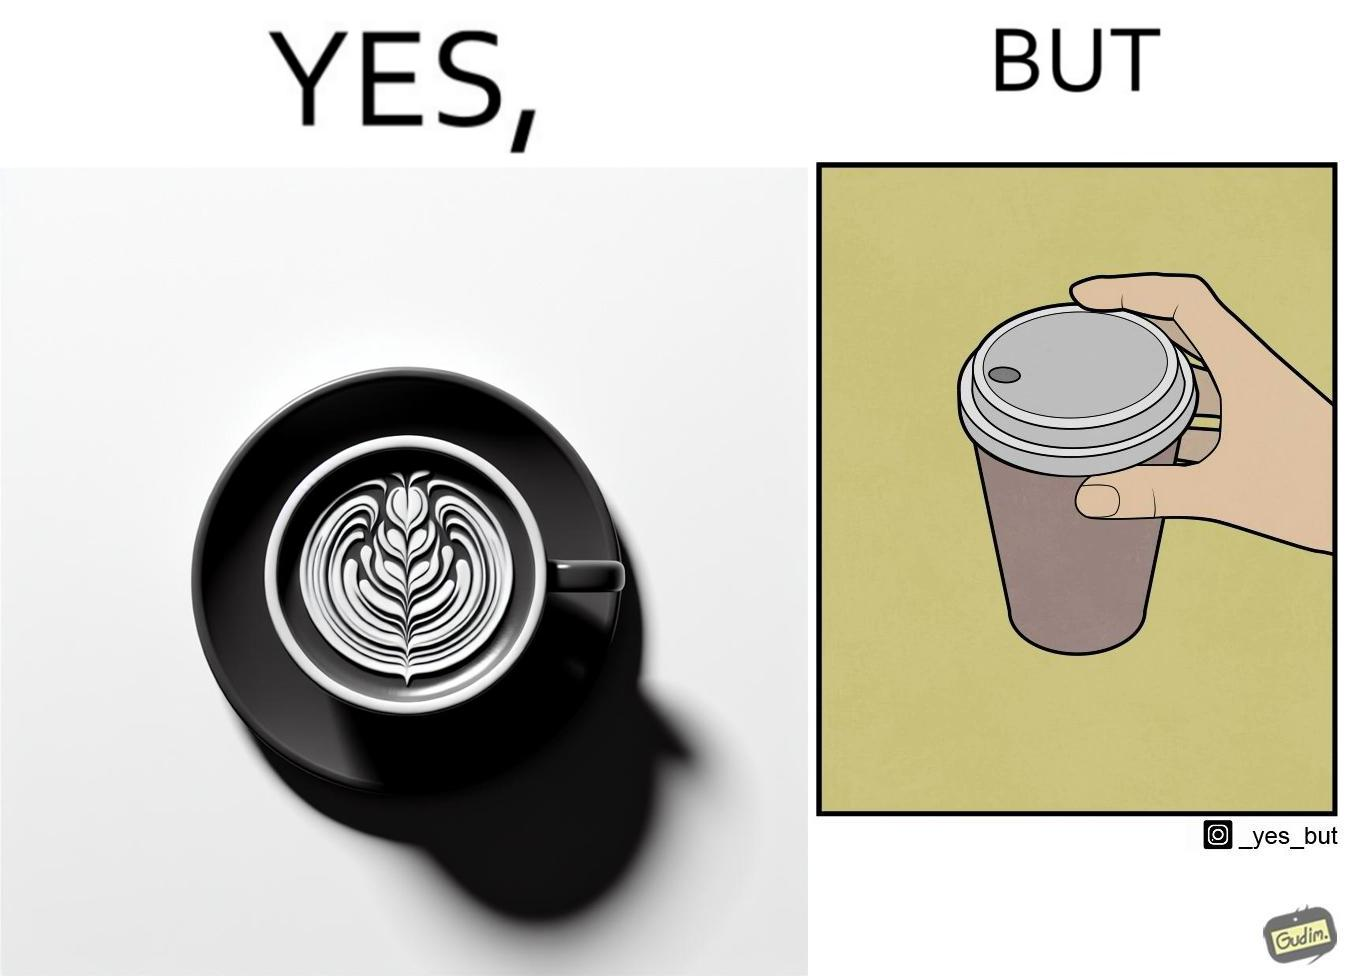Describe the content of this image. The images are funny since it shows how someone has put effort into a cup of coffee to do latte art on it only for it to be invisible after a lid is put on the coffee cup before serving to a customer 